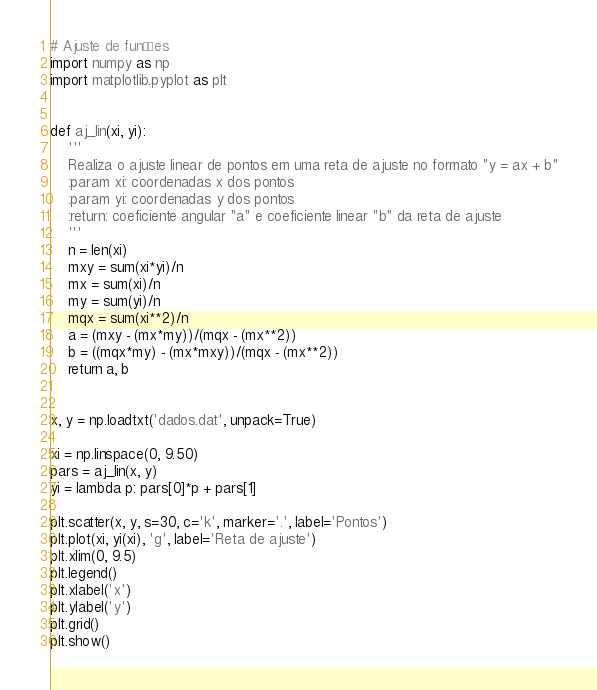Convert code to text. <code><loc_0><loc_0><loc_500><loc_500><_Python_># Ajuste de funções
import numpy as np
import matplotlib.pyplot as plt


def aj_lin(xi, yi):
    '''
    Realiza o ajuste linear de pontos em uma reta de ajuste no formato "y = ax + b"
    :param xi: coordenadas x dos pontos
    :param yi: coordenadas y dos pontos
    :return: coeficiente angular "a" e coeficiente linear "b" da reta de ajuste
    '''
    n = len(xi)
    mxy = sum(xi*yi)/n
    mx = sum(xi)/n
    my = sum(yi)/n
    mqx = sum(xi**2)/n
    a = (mxy - (mx*my))/(mqx - (mx**2))
    b = ((mqx*my) - (mx*mxy))/(mqx - (mx**2))
    return a, b


x, y = np.loadtxt('dados.dat', unpack=True)

xi = np.linspace(0, 9.50)
pars = aj_lin(x, y)
yi = lambda p: pars[0]*p + pars[1]

plt.scatter(x, y, s=30, c='k', marker='.', label='Pontos')
plt.plot(xi, yi(xi), 'g', label='Reta de ajuste')
plt.xlim(0, 9.5)
plt.legend()
plt.xlabel('x')
plt.ylabel('y')
plt.grid()
plt.show()

</code> 